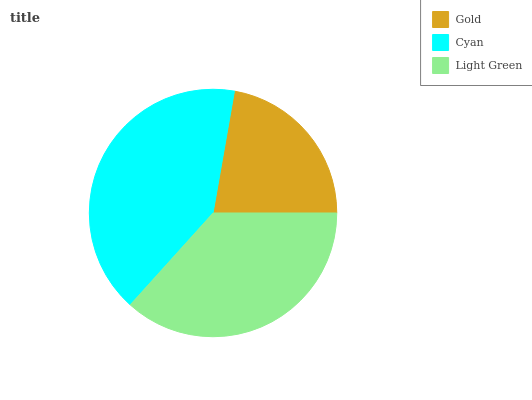Is Gold the minimum?
Answer yes or no. Yes. Is Cyan the maximum?
Answer yes or no. Yes. Is Light Green the minimum?
Answer yes or no. No. Is Light Green the maximum?
Answer yes or no. No. Is Cyan greater than Light Green?
Answer yes or no. Yes. Is Light Green less than Cyan?
Answer yes or no. Yes. Is Light Green greater than Cyan?
Answer yes or no. No. Is Cyan less than Light Green?
Answer yes or no. No. Is Light Green the high median?
Answer yes or no. Yes. Is Light Green the low median?
Answer yes or no. Yes. Is Cyan the high median?
Answer yes or no. No. Is Cyan the low median?
Answer yes or no. No. 